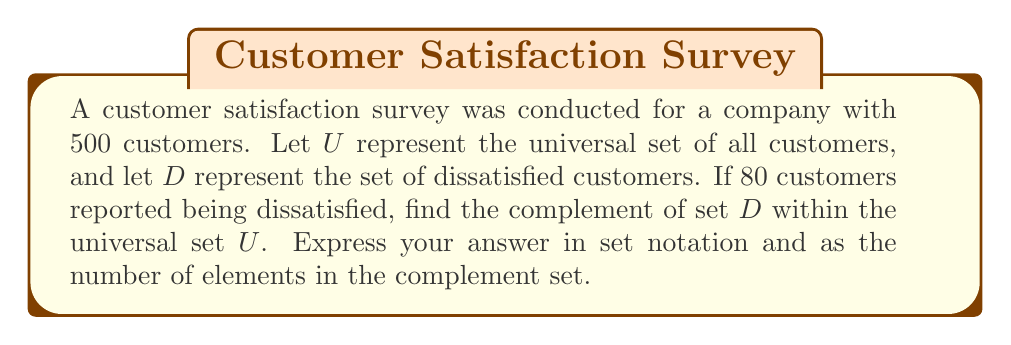Can you solve this math problem? To solve this problem, we need to follow these steps:

1. Identify the universal set $U$ and the set of dissatisfied customers $D$:
   $U = \text{all customers} = 500$
   $D = \text{dissatisfied customers} = 80$

2. Recall that the complement of a set $A$ within the universal set $U$ is denoted as $A^c$ or $\overline{A}$, and it consists of all elements in $U$ that are not in $A$.

3. In this case, we need to find $D^c$, which represents all customers who are not dissatisfied (i.e., satisfied customers).

4. To find the number of elements in $D^c$, we subtract the number of elements in $D$ from the total number of elements in $U$:

   $|D^c| = |U| - |D| = 500 - 80 = 420$

5. In set notation, we can express $D^c$ as:

   $D^c = \{x \in U | x \notin D\}$

   This reads as "the set of all elements $x$ in $U$ such that $x$ is not in $D$".

Therefore, the complement of set $D$ within the universal set $U$ contains 420 elements and can be expressed in set notation as shown above.
Answer: $D^c = \{x \in U | x \notin D\}$, where $|D^c| = 420$ 